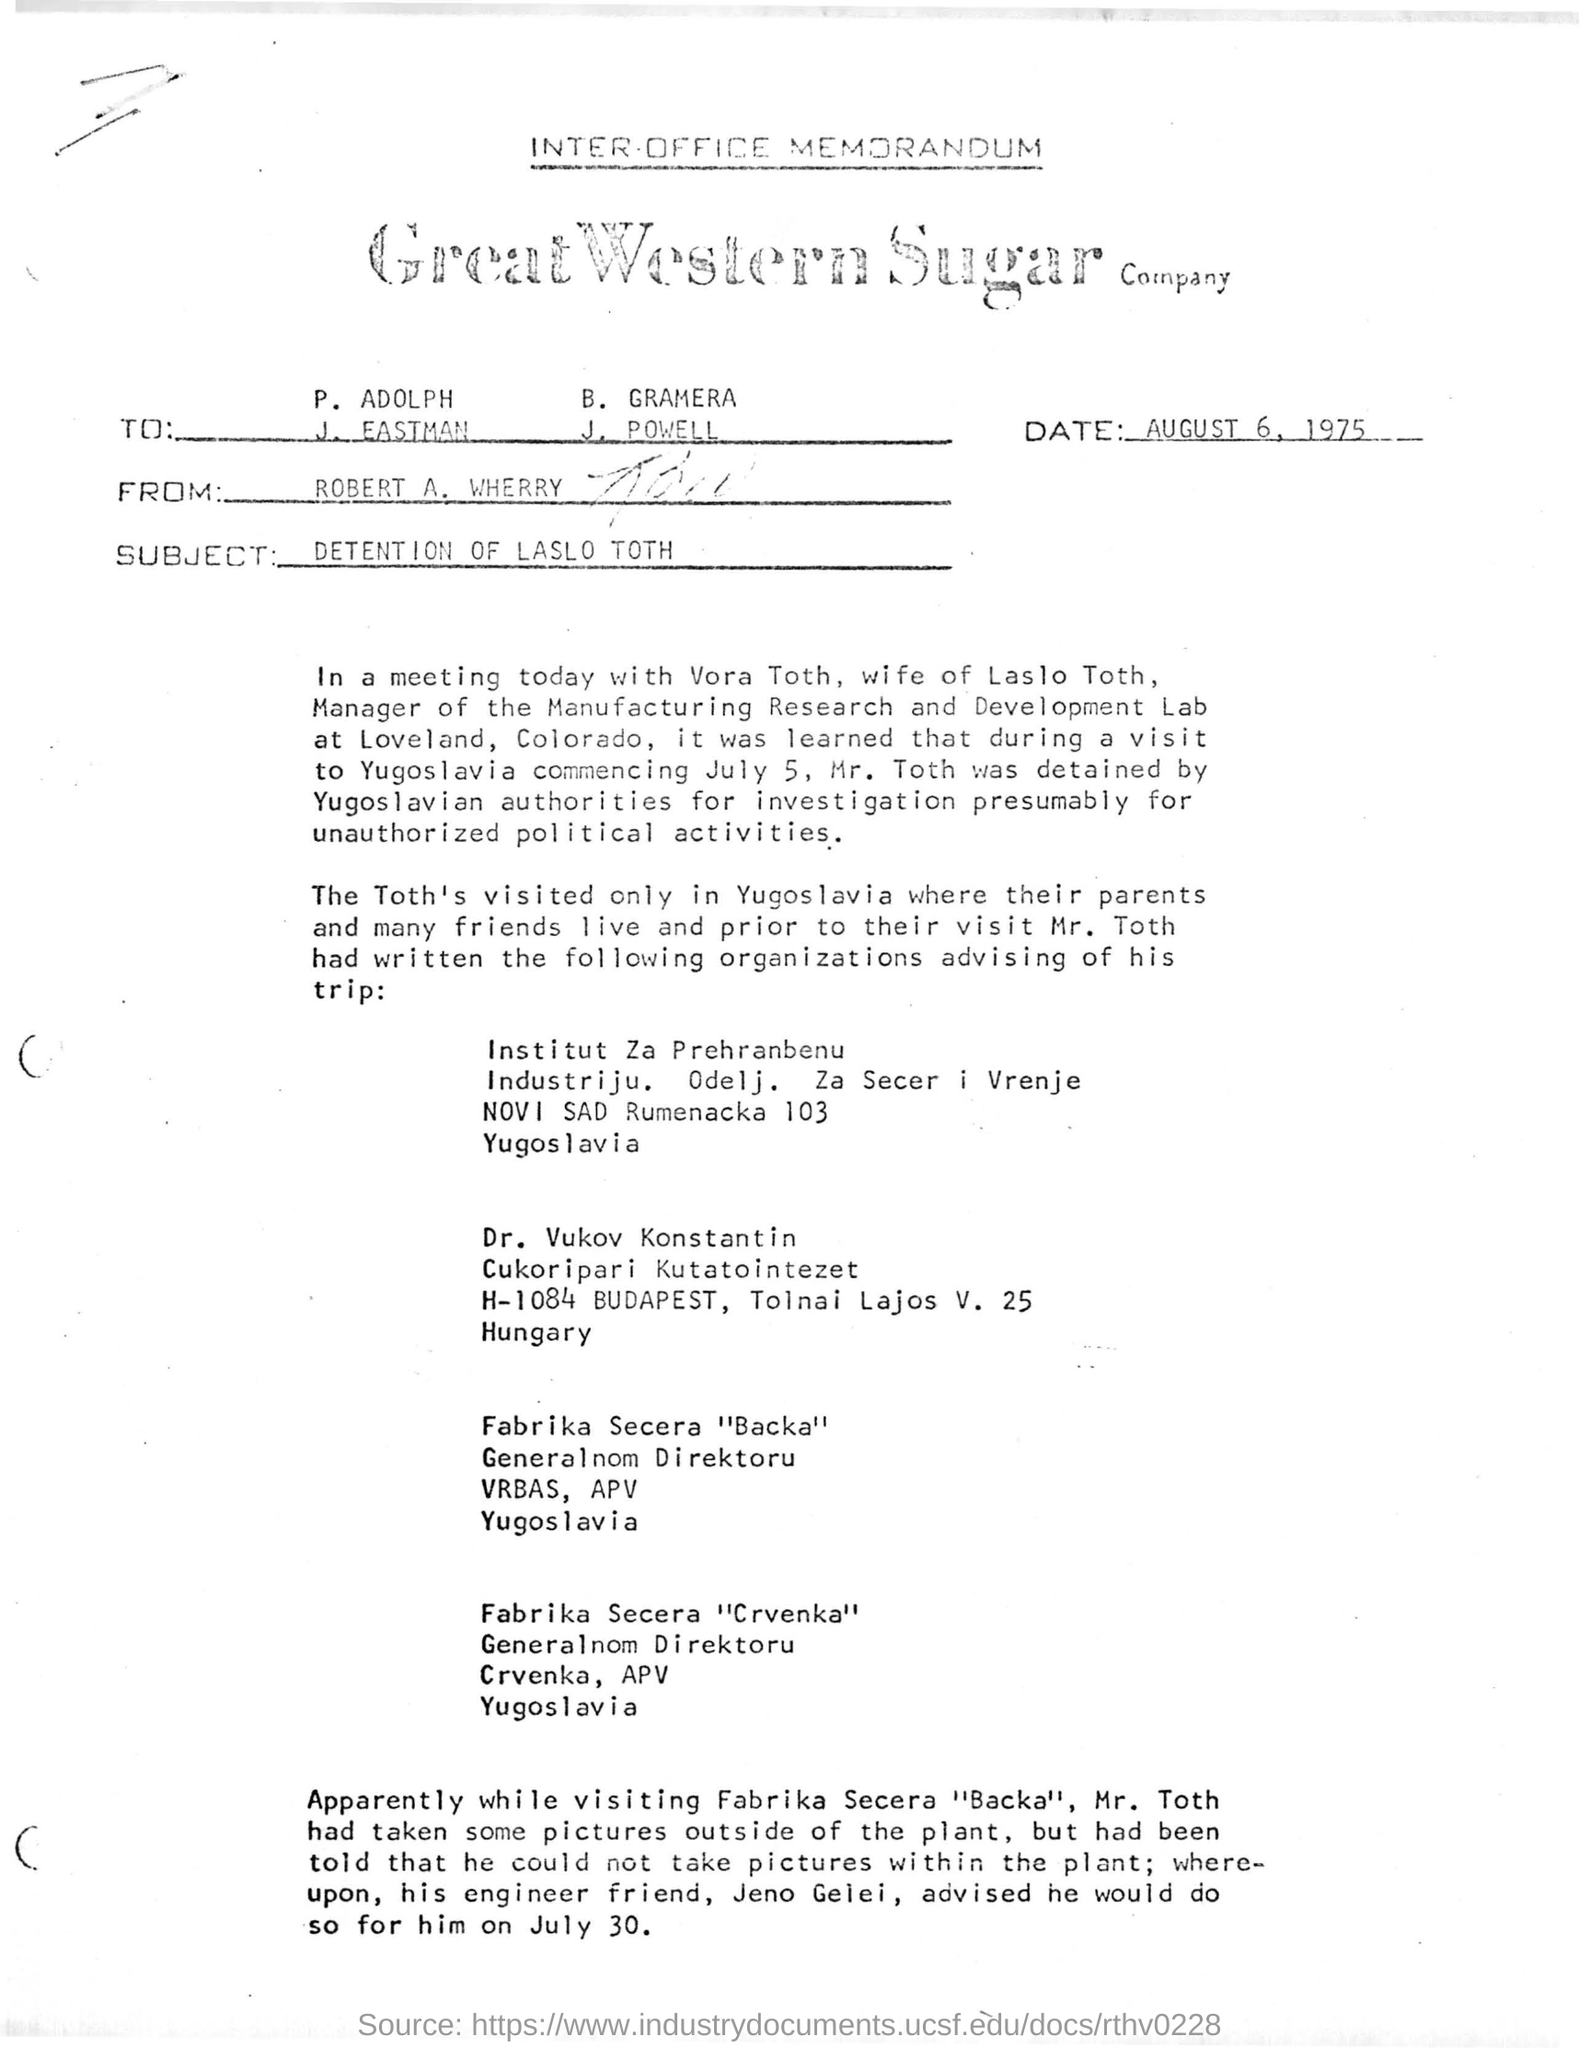Highlight a few significant elements in this photo. The sender of this message is Robert A. Wherry. This document is an Inter-Office Memorandum. Great Western Sugar Company is a company that is known for producing high-quality sugar products. The company is based in the western region of the country and is known for its excellent customer service and commitment to providing the best sugar products to its customers. The subject line of the document is 'DETENTION OF LASLO TOTH.' The date mentioned at the top of the document is August 6, 1975. 